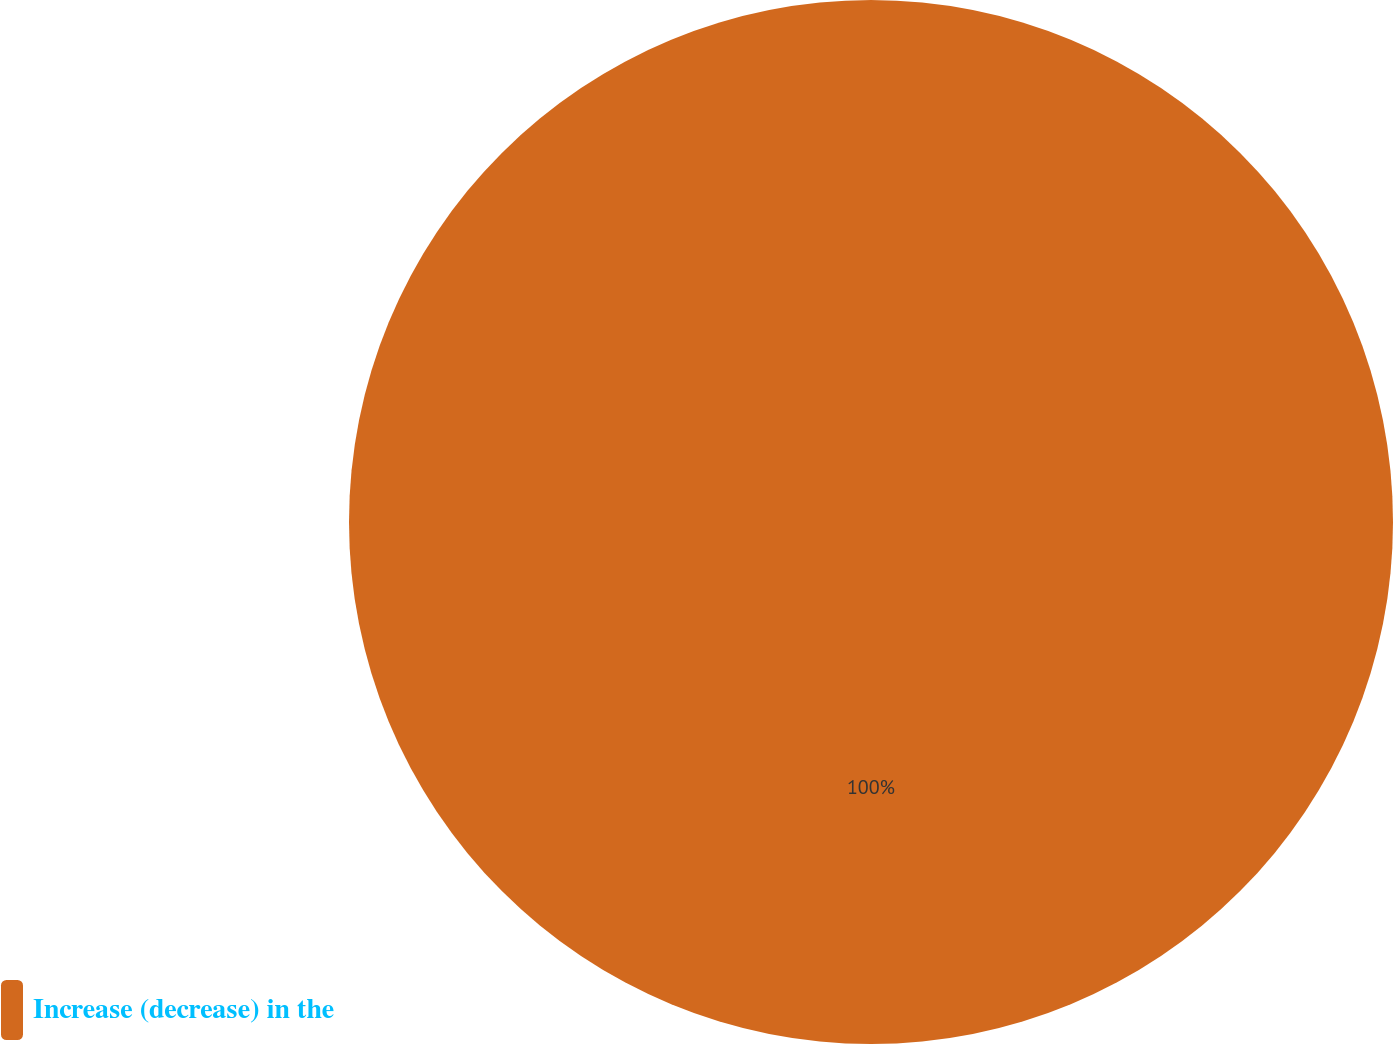Convert chart. <chart><loc_0><loc_0><loc_500><loc_500><pie_chart><fcel>Increase (decrease) in the<nl><fcel>100.0%<nl></chart> 